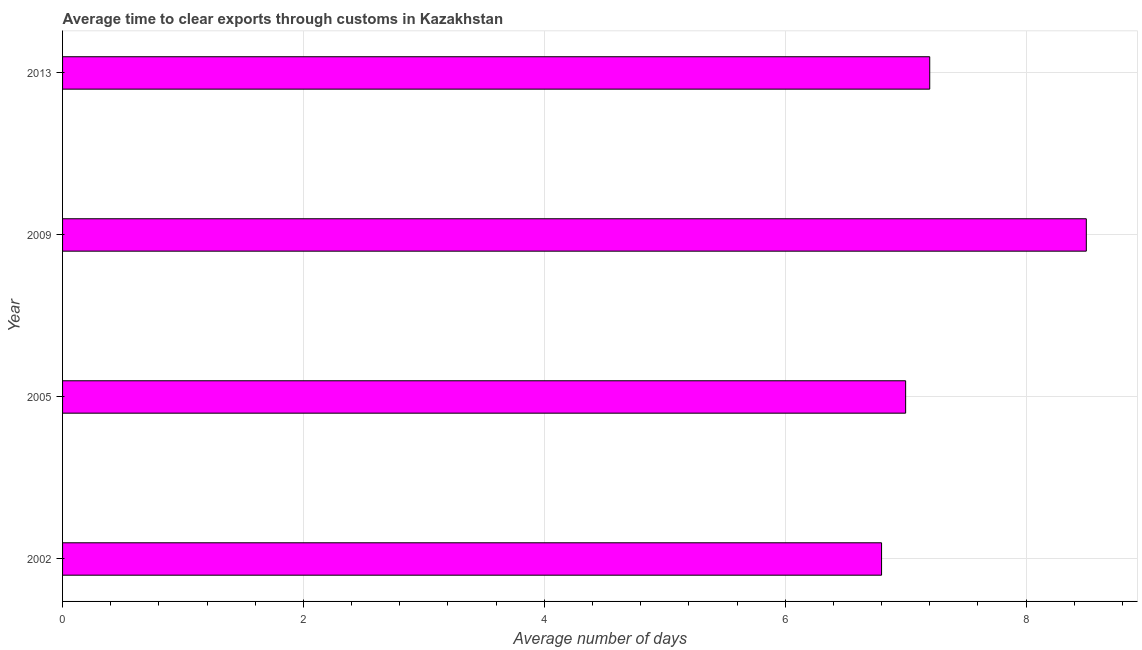Does the graph contain any zero values?
Give a very brief answer. No. What is the title of the graph?
Your answer should be compact. Average time to clear exports through customs in Kazakhstan. What is the label or title of the X-axis?
Ensure brevity in your answer.  Average number of days. Across all years, what is the maximum time to clear exports through customs?
Offer a terse response. 8.5. What is the sum of the time to clear exports through customs?
Your answer should be compact. 29.5. What is the difference between the time to clear exports through customs in 2002 and 2005?
Ensure brevity in your answer.  -0.2. What is the average time to clear exports through customs per year?
Offer a very short reply. 7.38. In how many years, is the time to clear exports through customs greater than 3.2 days?
Your answer should be compact. 4. What is the ratio of the time to clear exports through customs in 2002 to that in 2013?
Your answer should be compact. 0.94. Is the difference between the time to clear exports through customs in 2002 and 2013 greater than the difference between any two years?
Provide a short and direct response. No. What is the difference between the highest and the second highest time to clear exports through customs?
Provide a short and direct response. 1.3. Is the sum of the time to clear exports through customs in 2002 and 2005 greater than the maximum time to clear exports through customs across all years?
Offer a very short reply. Yes. What is the difference between the highest and the lowest time to clear exports through customs?
Offer a terse response. 1.7. How many years are there in the graph?
Your answer should be very brief. 4. What is the difference between two consecutive major ticks on the X-axis?
Offer a very short reply. 2. What is the difference between the Average number of days in 2002 and 2005?
Provide a succinct answer. -0.2. What is the difference between the Average number of days in 2005 and 2013?
Offer a very short reply. -0.2. What is the ratio of the Average number of days in 2002 to that in 2009?
Ensure brevity in your answer.  0.8. What is the ratio of the Average number of days in 2002 to that in 2013?
Offer a terse response. 0.94. What is the ratio of the Average number of days in 2005 to that in 2009?
Your response must be concise. 0.82. What is the ratio of the Average number of days in 2005 to that in 2013?
Ensure brevity in your answer.  0.97. What is the ratio of the Average number of days in 2009 to that in 2013?
Your response must be concise. 1.18. 